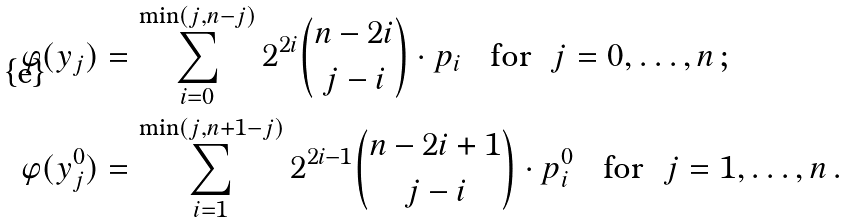<formula> <loc_0><loc_0><loc_500><loc_500>\varphi ( y _ { j } ) & = \sum _ { i = 0 } ^ { \min ( j , n - j ) } 2 ^ { 2 i } \binom { n - 2 i } { j - i } \cdot p _ { i } \text { \ \ for \ } j = 0 , \dots , n \, ; \\ \varphi ( y _ { j } ^ { 0 } ) & = \sum _ { i = 1 } ^ { \min ( j , n + 1 - j ) } 2 ^ { 2 i - 1 } \binom { n - 2 i + 1 } { j - i } \cdot p ^ { 0 } _ { i } \text { \ \ for \ } j = 1 , \dots , n \, .</formula> 